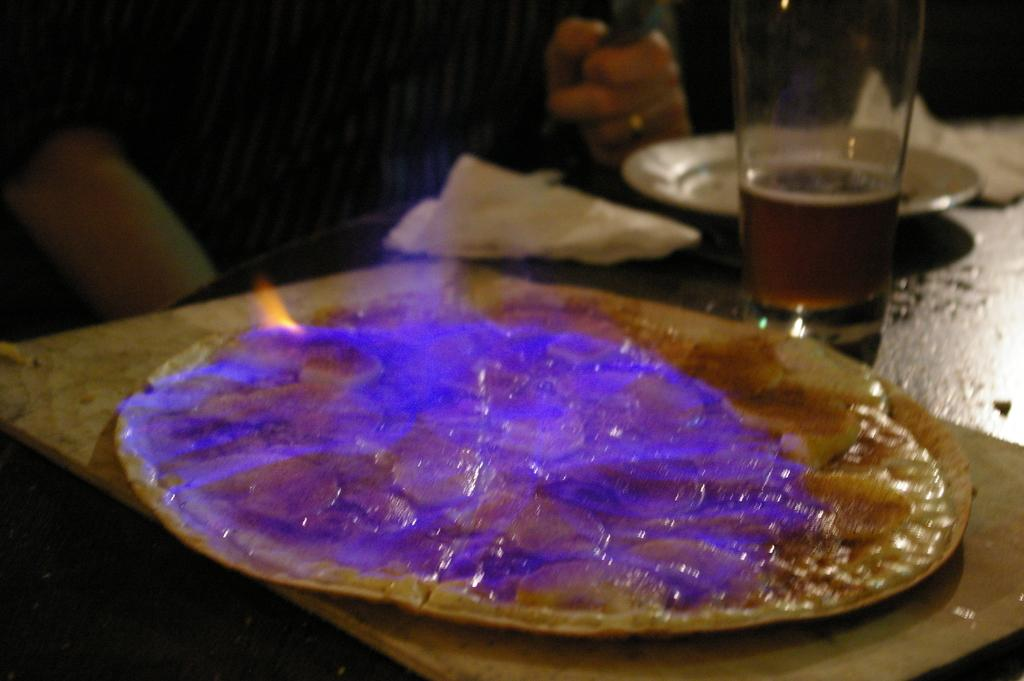What type of dishware can be seen in the image? There are plates in the image. What else is present for table setting purposes? There are napkins and a glass visible in the image. What is on one of the plates? There is food on one of the plates. Can you describe the presence of a person in the image? There are hands of a person visible in the background. What type of story is being told by the goose in the image? There is no goose present in the image, so no story can be told by a goose. Is there a prison visible in the image? There is no prison present in the image. 